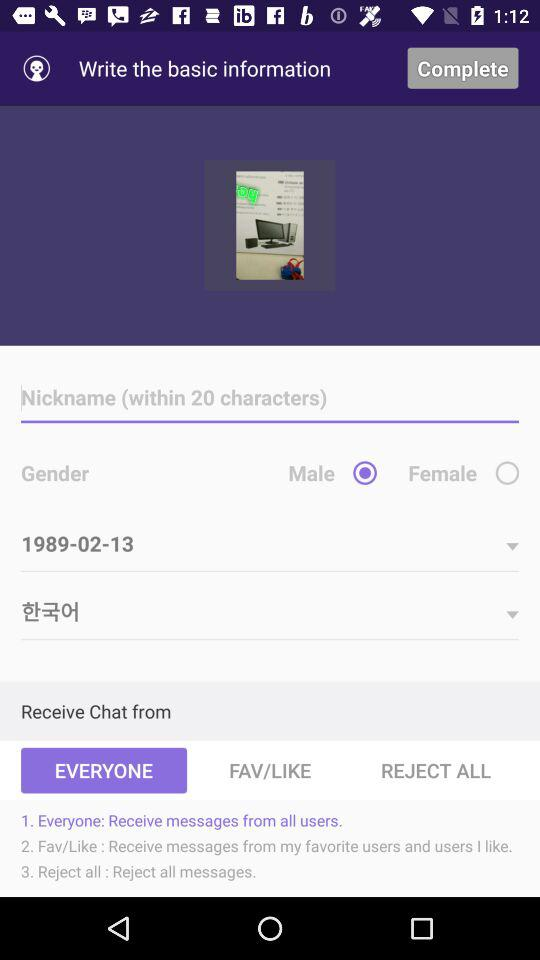What is the selected date of birth? The selected date of birth is 1989-02-13. 